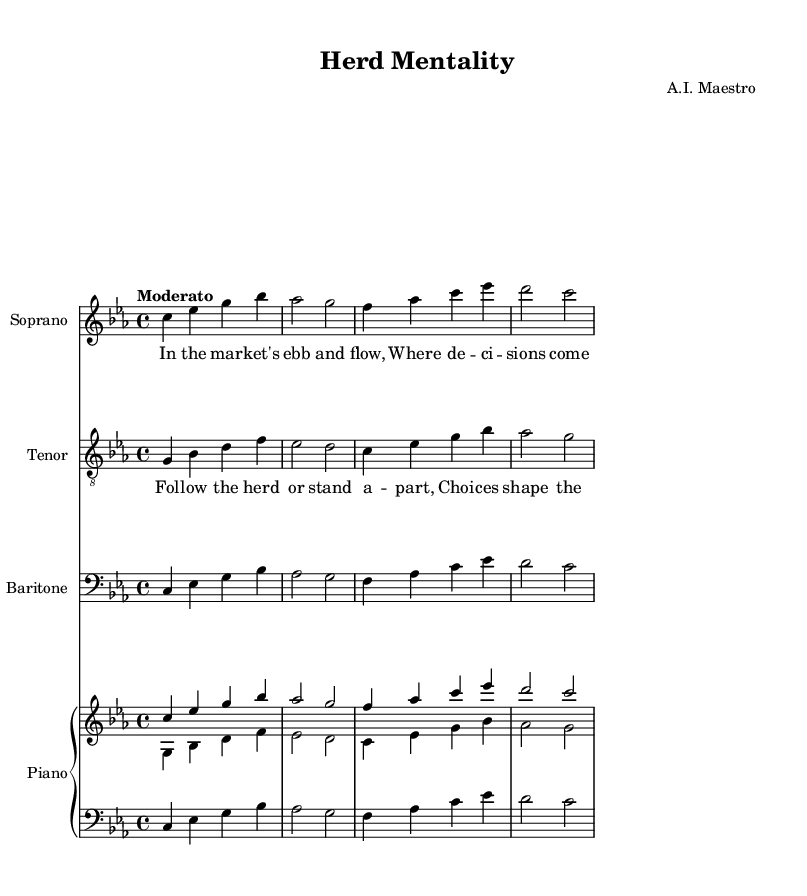What is the key signature of the piece? The key signature is indicated at the beginning of the staff, and it shows three flat symbols, which indicates C minor.
Answer: C minor What is the time signature of this music? The time signature is shown at the beginning of the staff next to the clef sign, and it is indicated as 4 over 4.
Answer: 4/4 What tempo marking is indicated? The tempo marking is provided in Italian and specifies the speed of the piece, which is marked as "Moderato."
Answer: Moderato How many voices are there in the opera piece? The music contains three distinct voices, which are identified as soprano, tenor, and baritone, each with its own staff.
Answer: Three What is the theme of the lyrics sung by the chorus? The lyrics in the chorus reflect a theme of collective behavior and the impact of group decisions in the market, emphasizing following the herd.
Answer: Following the herd or stand apart Which instrument plays the accompaniment for the vocal parts? The sheet music includes a piano staff that supports the vocal lines, as indicated by the presence of a separate PianoStaff section.
Answer: Piano What is the title of the opera? The title is indicated in the header section of the sheet music and describes the main concept explored in the opera.
Answer: Herd Mentality 